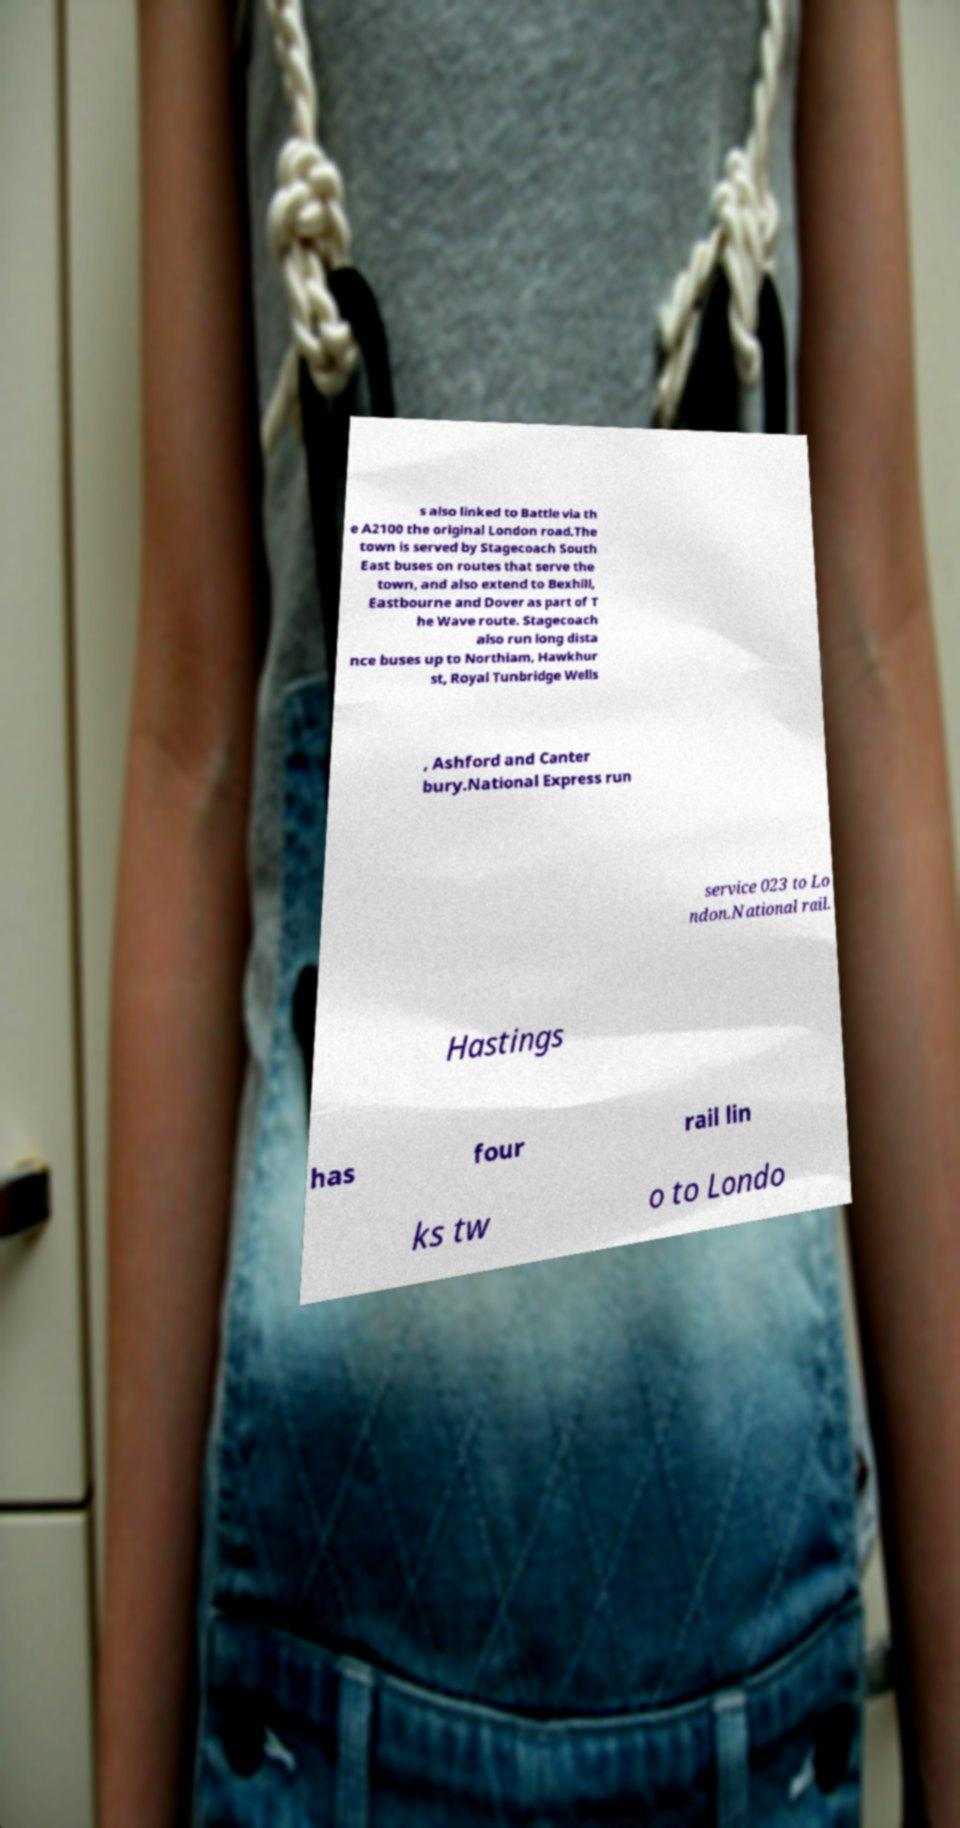Could you assist in decoding the text presented in this image and type it out clearly? s also linked to Battle via th e A2100 the original London road.The town is served by Stagecoach South East buses on routes that serve the town, and also extend to Bexhill, Eastbourne and Dover as part of T he Wave route. Stagecoach also run long dista nce buses up to Northiam, Hawkhur st, Royal Tunbridge Wells , Ashford and Canter bury.National Express run service 023 to Lo ndon.National rail. Hastings has four rail lin ks tw o to Londo 